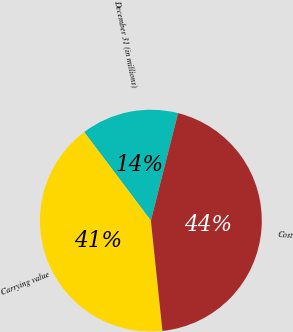Convert chart. <chart><loc_0><loc_0><loc_500><loc_500><pie_chart><fcel>December 31 (in millions)<fcel>Carrying value<fcel>Cost<nl><fcel>14.21%<fcel>41.39%<fcel>44.4%<nl></chart> 